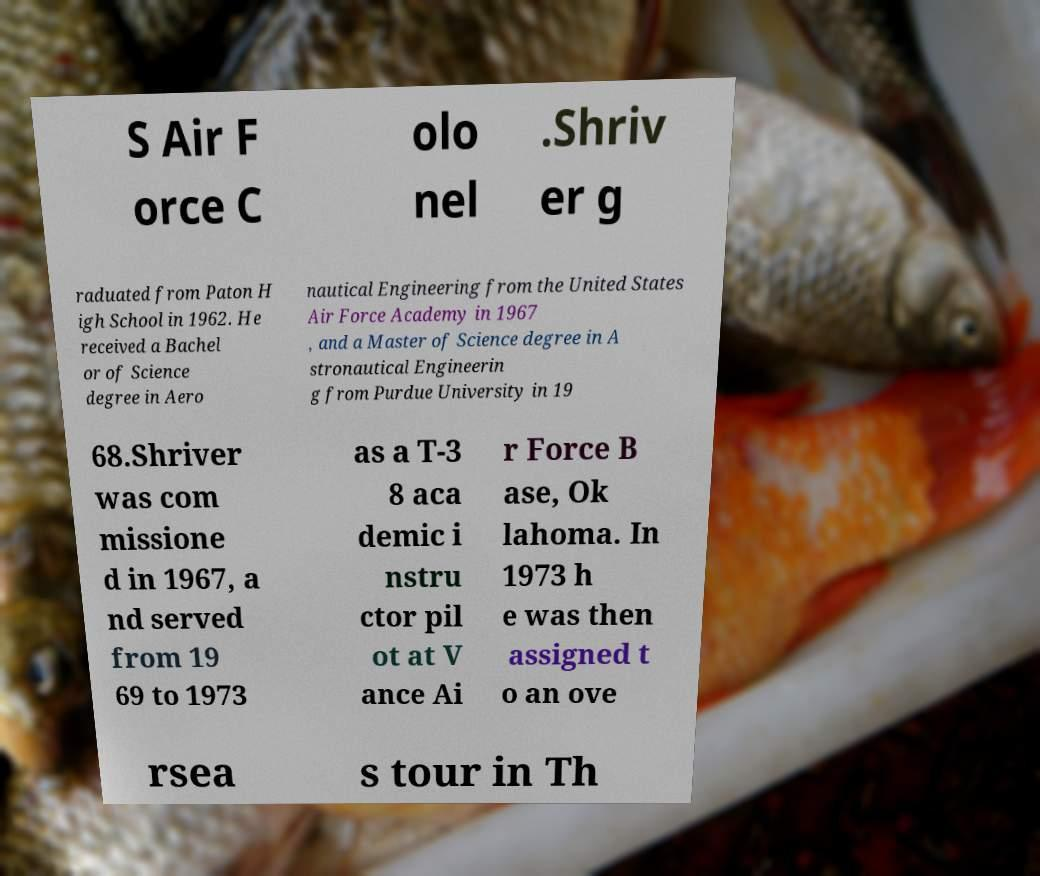Can you accurately transcribe the text from the provided image for me? S Air F orce C olo nel .Shriv er g raduated from Paton H igh School in 1962. He received a Bachel or of Science degree in Aero nautical Engineering from the United States Air Force Academy in 1967 , and a Master of Science degree in A stronautical Engineerin g from Purdue University in 19 68.Shriver was com missione d in 1967, a nd served from 19 69 to 1973 as a T-3 8 aca demic i nstru ctor pil ot at V ance Ai r Force B ase, Ok lahoma. In 1973 h e was then assigned t o an ove rsea s tour in Th 